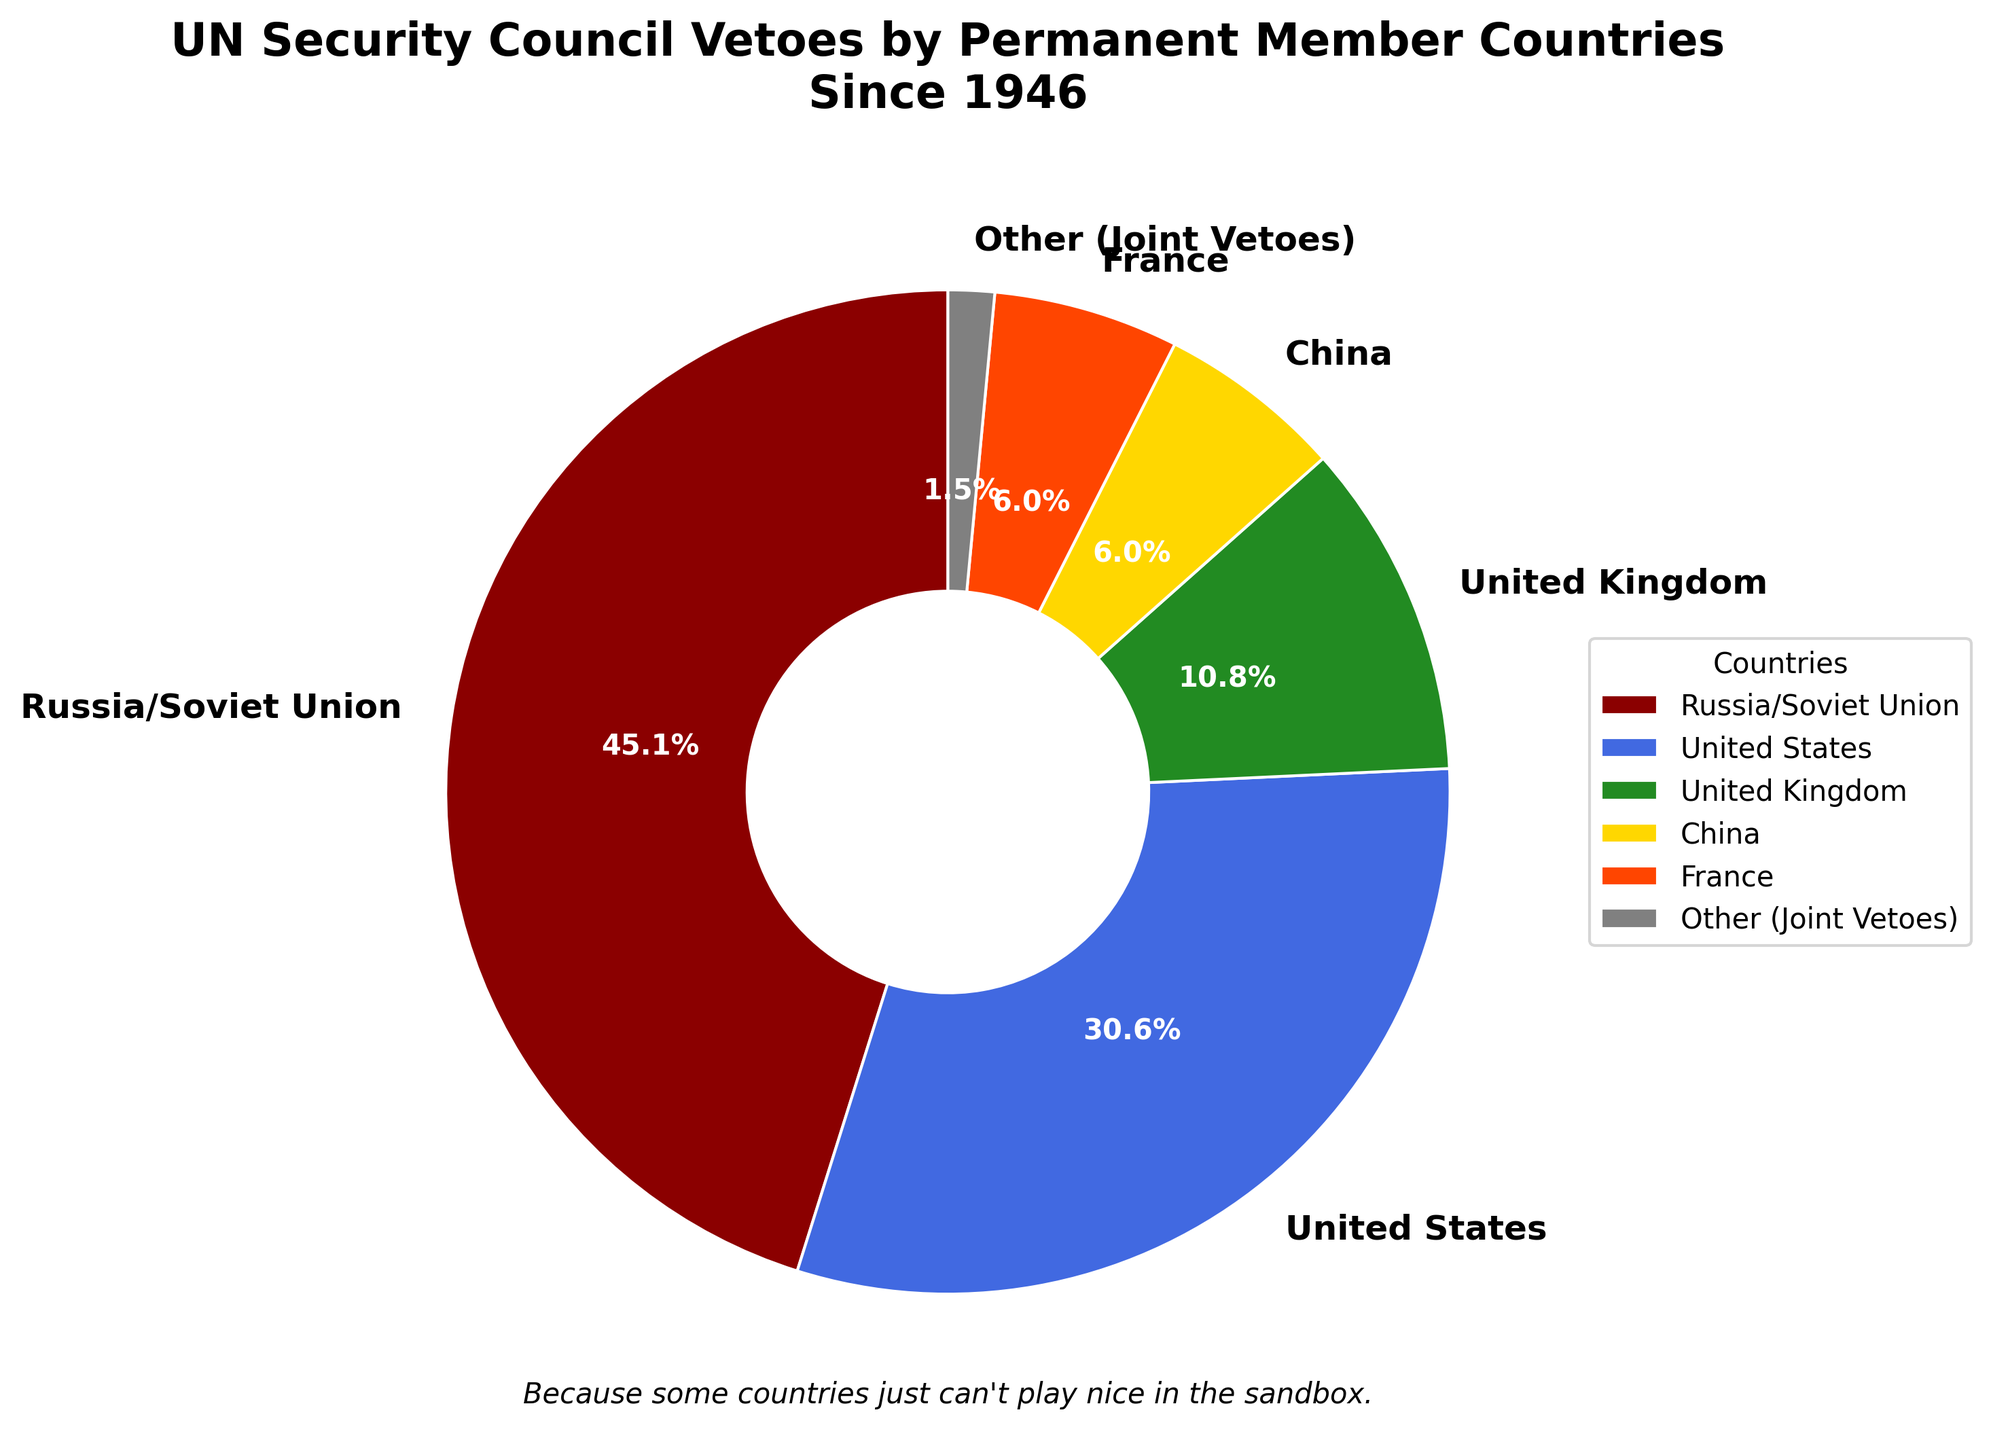Which country has cast the most vetoes? To determine which country has cast the most vetoes, look at the size of each section in the pie chart and identify the largest segment. The largest segment represents Russia/Soviet Union.
Answer: Russia/Soviet Union What is the combined percentage of vetoes by China and France? To find the combined percentage of vetoes by China and France, sum their individual percentages as shown in the pie chart. Both China and France have 5.3% each (5.3% + 5.3%).
Answer: 10.6% Which country has the smallest portion of the pie chart? Identify the smallest segment in the pie chart. The smallest segment is labeled "Other (Joint Vetoes)."
Answer: Other (Joint Vetoes) How many more vetoes has the United States cast compared to the United Kingdom? First, find the number of vetoes by the United States and the United Kingdom from the chart: 82 for the United States and 29 for the United Kingdom. Then, subtract the number of vetoes by the United Kingdom from the United States (82 - 29).
Answer: 53 Which countries have contributed exactly 16 vetoes each? Identify all segments that show 16 vetoes. Both China and France have 16 vetoes each as indicated in the pie chart.
Answer: China and France What percentage of the pie chart does the "Other (Joint Vetoes)" category occupy? Look at the pie chart and find the percentage label for "Other (Joint Vetoes)." This category occupies 1.3% of the pie chart.
Answer: 1.3% How does the number of vetoes cast by the United Kingdom compare to that cast by China? Compare the number of vetoes by the United Kingdom (29) with those by China (16) from the chart. The United Kingdom has cast more vetoes than China.
Answer: United Kingdom has cast more What is the total number of vetoes cast by all five permanent members of the UN Security Council and joint vetoes? Sum the number of vetoes cast by each country: 121 (Russia/Soviet Union) + 82 (United States) + 29 (United Kingdom) + 16 (China) + 16 (France) + 4 (Other). The total is 268.
Answer: 268 